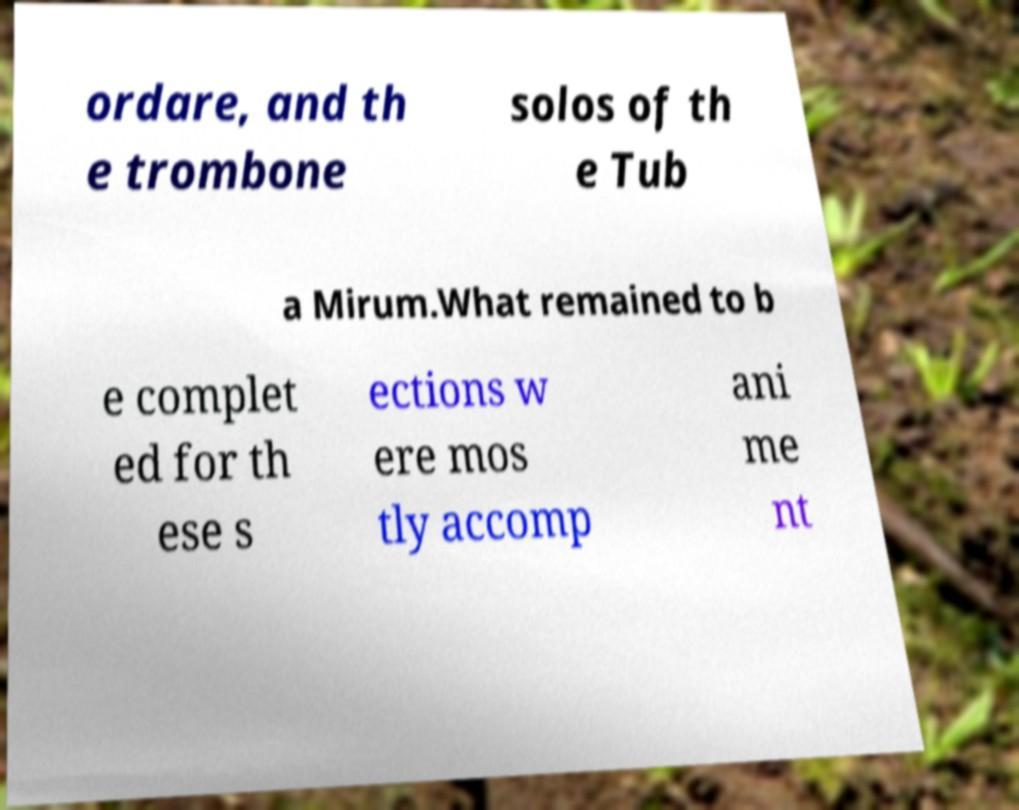Can you read and provide the text displayed in the image?This photo seems to have some interesting text. Can you extract and type it out for me? ordare, and th e trombone solos of th e Tub a Mirum.What remained to b e complet ed for th ese s ections w ere mos tly accomp ani me nt 